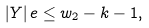<formula> <loc_0><loc_0><loc_500><loc_500>| Y | \, e \leq w _ { 2 } - k - 1 ,</formula> 